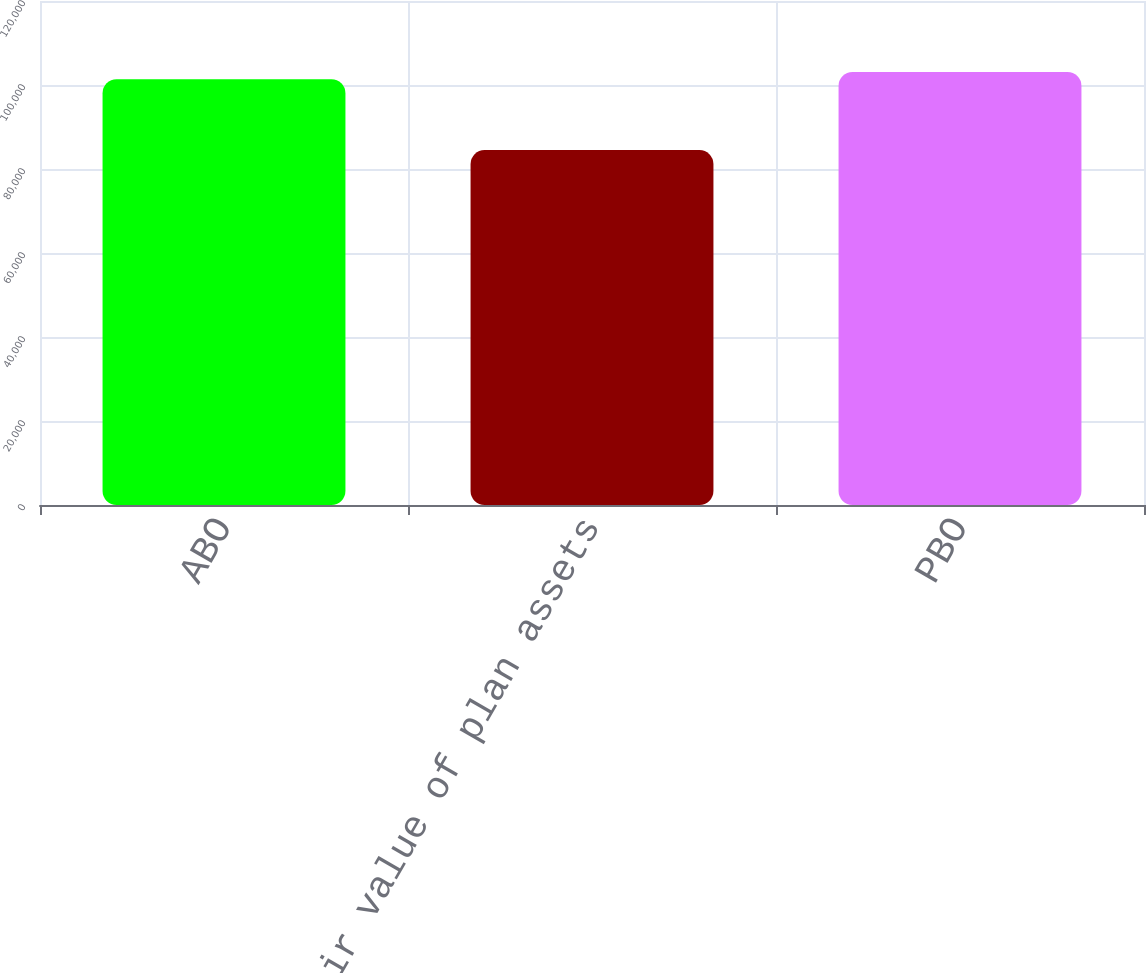Convert chart. <chart><loc_0><loc_0><loc_500><loc_500><bar_chart><fcel>ABO<fcel>Fair value of plan assets<fcel>PBO<nl><fcel>101397<fcel>84500<fcel>103104<nl></chart> 